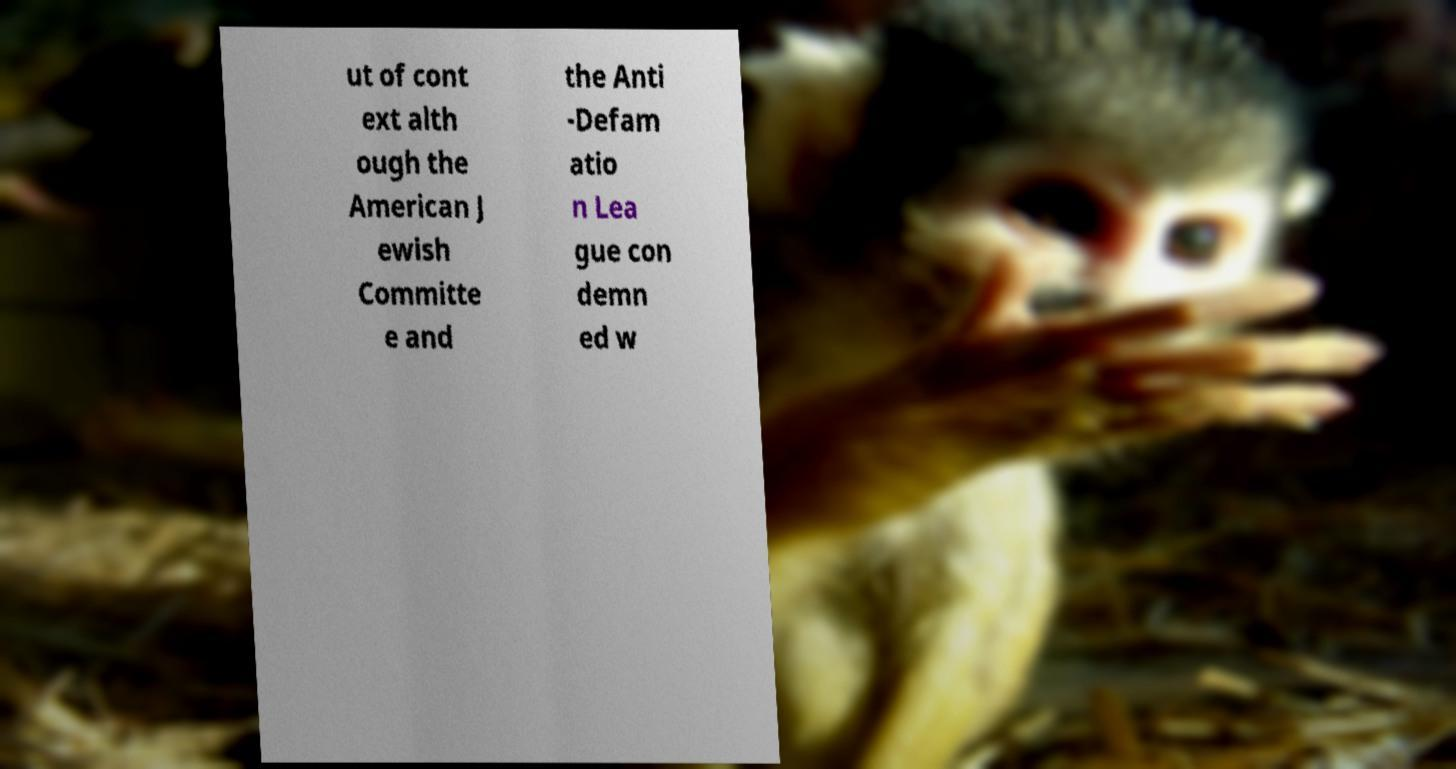What messages or text are displayed in this image? I need them in a readable, typed format. ut of cont ext alth ough the American J ewish Committe e and the Anti -Defam atio n Lea gue con demn ed w 